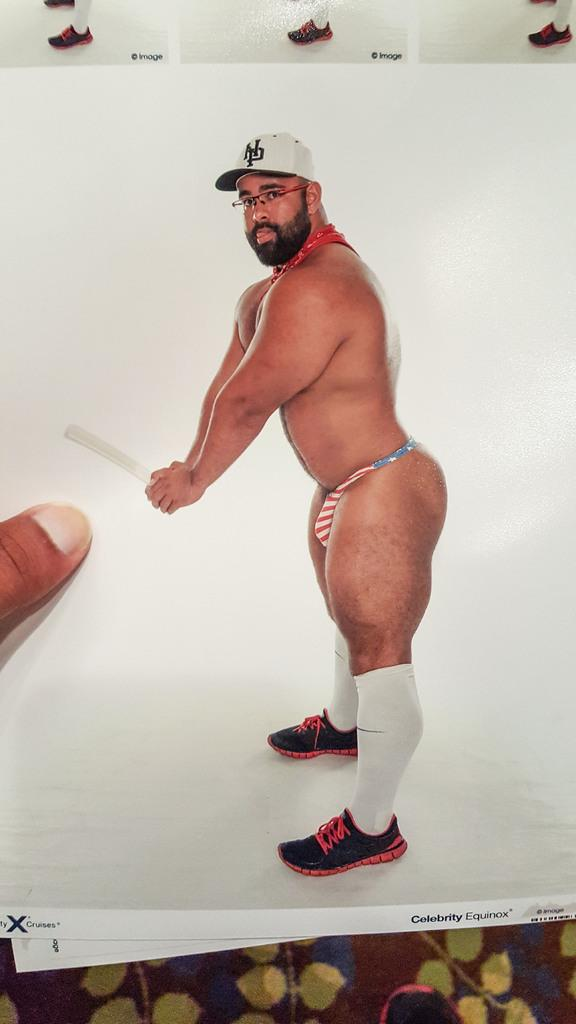What is the main subject of the image? There is a photo in the image. Can you describe the person in the photo? The photo contains a man standing, and he is wearing a cap. What is the man holding in the photo? The man is holding an object in the photo. Are there any body parts of other people visible in the image? Yes, there are legs of one or more persons visible in the image. What type of birds can be seen flying in the image? There are no birds visible in the image; it features a photo of a man standing and holding an object. Can you tell me what kind of wax the man is using in the photo? There is no wax present in the image; the man is simply holding an object. 